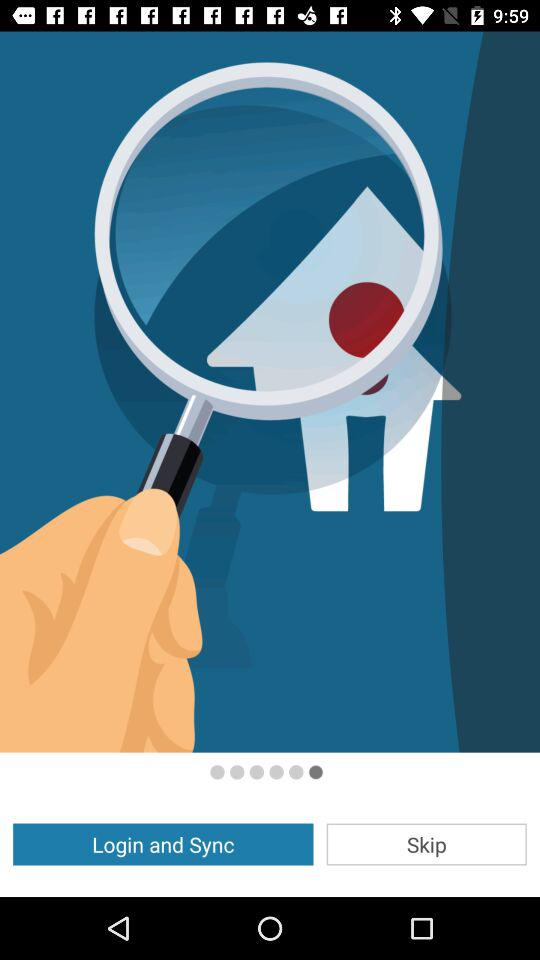Is this page skipped?
When the provided information is insufficient, respond with <no answer>. <no answer> 